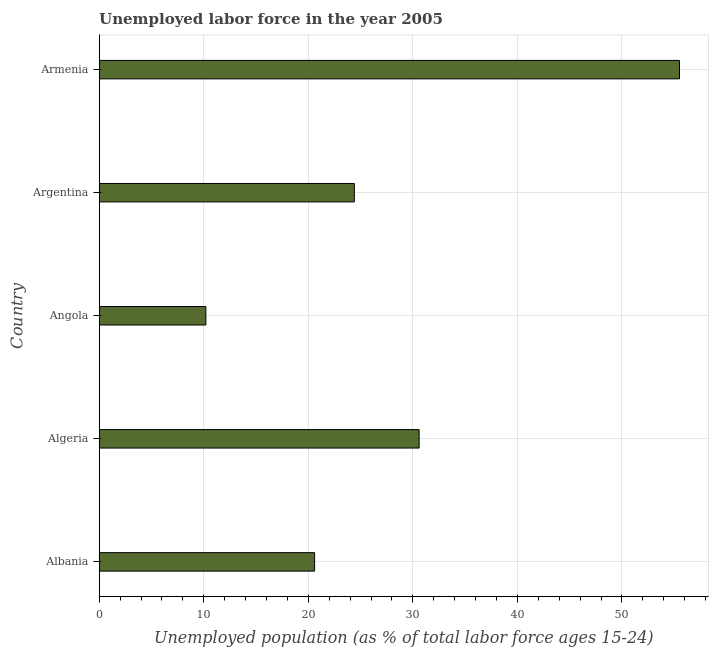Does the graph contain any zero values?
Give a very brief answer. No. What is the title of the graph?
Offer a very short reply. Unemployed labor force in the year 2005. What is the label or title of the X-axis?
Your answer should be very brief. Unemployed population (as % of total labor force ages 15-24). What is the label or title of the Y-axis?
Keep it short and to the point. Country. What is the total unemployed youth population in Angola?
Provide a short and direct response. 10.2. Across all countries, what is the maximum total unemployed youth population?
Give a very brief answer. 55.5. Across all countries, what is the minimum total unemployed youth population?
Your answer should be compact. 10.2. In which country was the total unemployed youth population maximum?
Offer a terse response. Armenia. In which country was the total unemployed youth population minimum?
Your answer should be very brief. Angola. What is the sum of the total unemployed youth population?
Your answer should be very brief. 141.3. What is the difference between the total unemployed youth population in Albania and Argentina?
Make the answer very short. -3.8. What is the average total unemployed youth population per country?
Offer a very short reply. 28.26. What is the median total unemployed youth population?
Offer a terse response. 24.4. In how many countries, is the total unemployed youth population greater than 40 %?
Offer a terse response. 1. What is the ratio of the total unemployed youth population in Angola to that in Armenia?
Ensure brevity in your answer.  0.18. Is the total unemployed youth population in Angola less than that in Argentina?
Ensure brevity in your answer.  Yes. Is the difference between the total unemployed youth population in Algeria and Armenia greater than the difference between any two countries?
Ensure brevity in your answer.  No. What is the difference between the highest and the second highest total unemployed youth population?
Your answer should be very brief. 24.9. What is the difference between the highest and the lowest total unemployed youth population?
Your answer should be very brief. 45.3. In how many countries, is the total unemployed youth population greater than the average total unemployed youth population taken over all countries?
Your answer should be compact. 2. How many bars are there?
Your response must be concise. 5. How many countries are there in the graph?
Offer a terse response. 5. What is the difference between two consecutive major ticks on the X-axis?
Your answer should be compact. 10. Are the values on the major ticks of X-axis written in scientific E-notation?
Your response must be concise. No. What is the Unemployed population (as % of total labor force ages 15-24) of Albania?
Provide a short and direct response. 20.6. What is the Unemployed population (as % of total labor force ages 15-24) in Algeria?
Keep it short and to the point. 30.6. What is the Unemployed population (as % of total labor force ages 15-24) of Angola?
Your answer should be compact. 10.2. What is the Unemployed population (as % of total labor force ages 15-24) in Argentina?
Offer a very short reply. 24.4. What is the Unemployed population (as % of total labor force ages 15-24) of Armenia?
Ensure brevity in your answer.  55.5. What is the difference between the Unemployed population (as % of total labor force ages 15-24) in Albania and Argentina?
Offer a very short reply. -3.8. What is the difference between the Unemployed population (as % of total labor force ages 15-24) in Albania and Armenia?
Offer a very short reply. -34.9. What is the difference between the Unemployed population (as % of total labor force ages 15-24) in Algeria and Angola?
Your response must be concise. 20.4. What is the difference between the Unemployed population (as % of total labor force ages 15-24) in Algeria and Argentina?
Offer a very short reply. 6.2. What is the difference between the Unemployed population (as % of total labor force ages 15-24) in Algeria and Armenia?
Your answer should be very brief. -24.9. What is the difference between the Unemployed population (as % of total labor force ages 15-24) in Angola and Armenia?
Provide a succinct answer. -45.3. What is the difference between the Unemployed population (as % of total labor force ages 15-24) in Argentina and Armenia?
Provide a succinct answer. -31.1. What is the ratio of the Unemployed population (as % of total labor force ages 15-24) in Albania to that in Algeria?
Your response must be concise. 0.67. What is the ratio of the Unemployed population (as % of total labor force ages 15-24) in Albania to that in Angola?
Ensure brevity in your answer.  2.02. What is the ratio of the Unemployed population (as % of total labor force ages 15-24) in Albania to that in Argentina?
Make the answer very short. 0.84. What is the ratio of the Unemployed population (as % of total labor force ages 15-24) in Albania to that in Armenia?
Offer a terse response. 0.37. What is the ratio of the Unemployed population (as % of total labor force ages 15-24) in Algeria to that in Angola?
Offer a terse response. 3. What is the ratio of the Unemployed population (as % of total labor force ages 15-24) in Algeria to that in Argentina?
Your answer should be compact. 1.25. What is the ratio of the Unemployed population (as % of total labor force ages 15-24) in Algeria to that in Armenia?
Offer a terse response. 0.55. What is the ratio of the Unemployed population (as % of total labor force ages 15-24) in Angola to that in Argentina?
Your answer should be compact. 0.42. What is the ratio of the Unemployed population (as % of total labor force ages 15-24) in Angola to that in Armenia?
Provide a succinct answer. 0.18. What is the ratio of the Unemployed population (as % of total labor force ages 15-24) in Argentina to that in Armenia?
Your answer should be very brief. 0.44. 